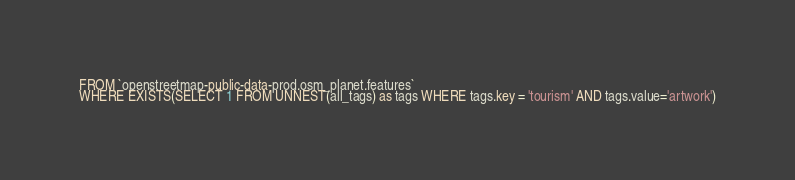<code> <loc_0><loc_0><loc_500><loc_500><_SQL_>FROM `openstreetmap-public-data-prod.osm_planet.features`
WHERE EXISTS(SELECT 1 FROM UNNEST(all_tags) as tags WHERE tags.key = 'tourism' AND tags.value='artwork')
</code> 